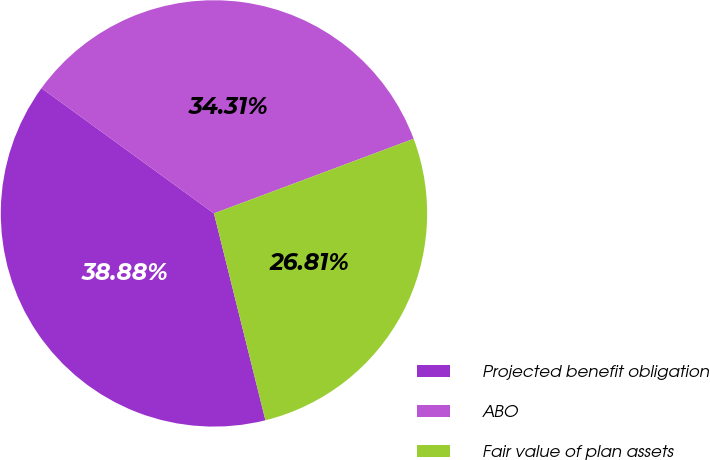Convert chart to OTSL. <chart><loc_0><loc_0><loc_500><loc_500><pie_chart><fcel>Projected benefit obligation<fcel>ABO<fcel>Fair value of plan assets<nl><fcel>38.88%<fcel>34.31%<fcel>26.81%<nl></chart> 